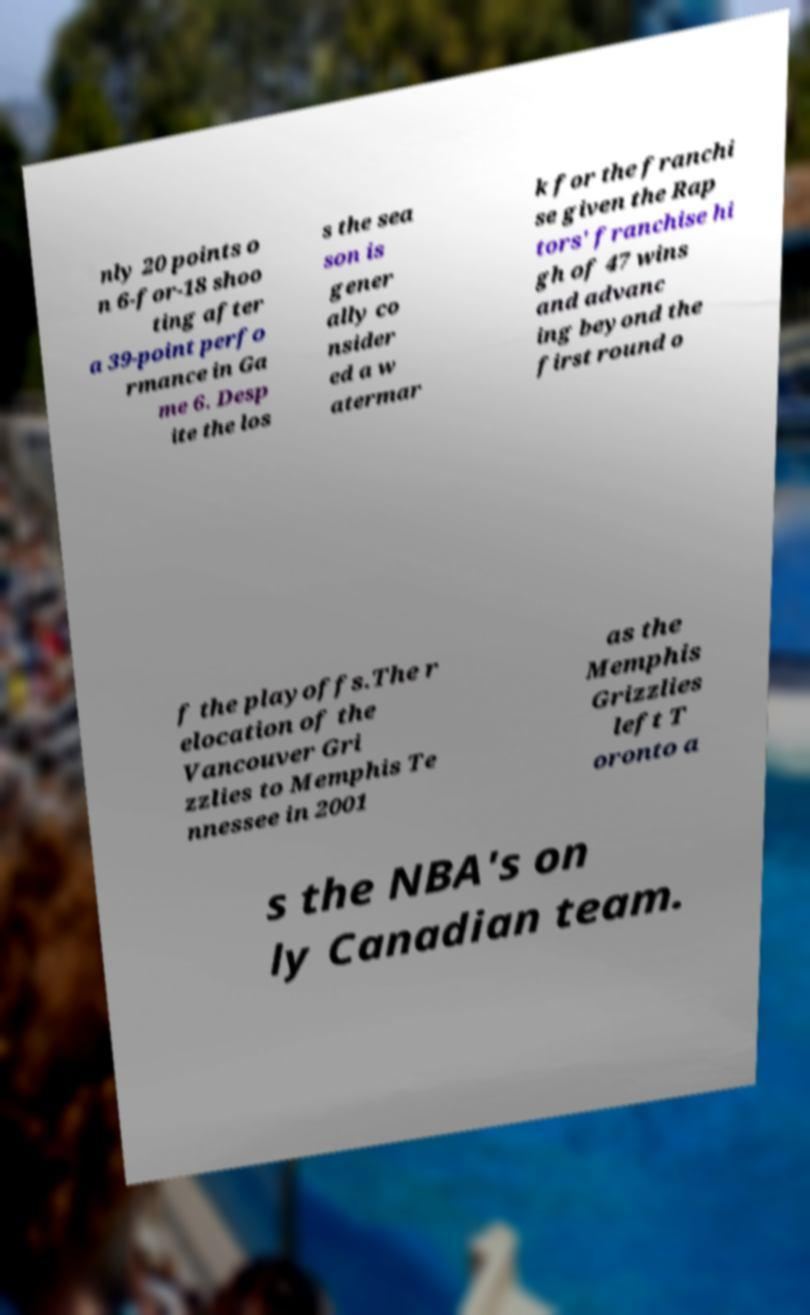Could you extract and type out the text from this image? nly 20 points o n 6-for-18 shoo ting after a 39-point perfo rmance in Ga me 6. Desp ite the los s the sea son is gener ally co nsider ed a w atermar k for the franchi se given the Rap tors' franchise hi gh of 47 wins and advanc ing beyond the first round o f the playoffs.The r elocation of the Vancouver Gri zzlies to Memphis Te nnessee in 2001 as the Memphis Grizzlies left T oronto a s the NBA's on ly Canadian team. 